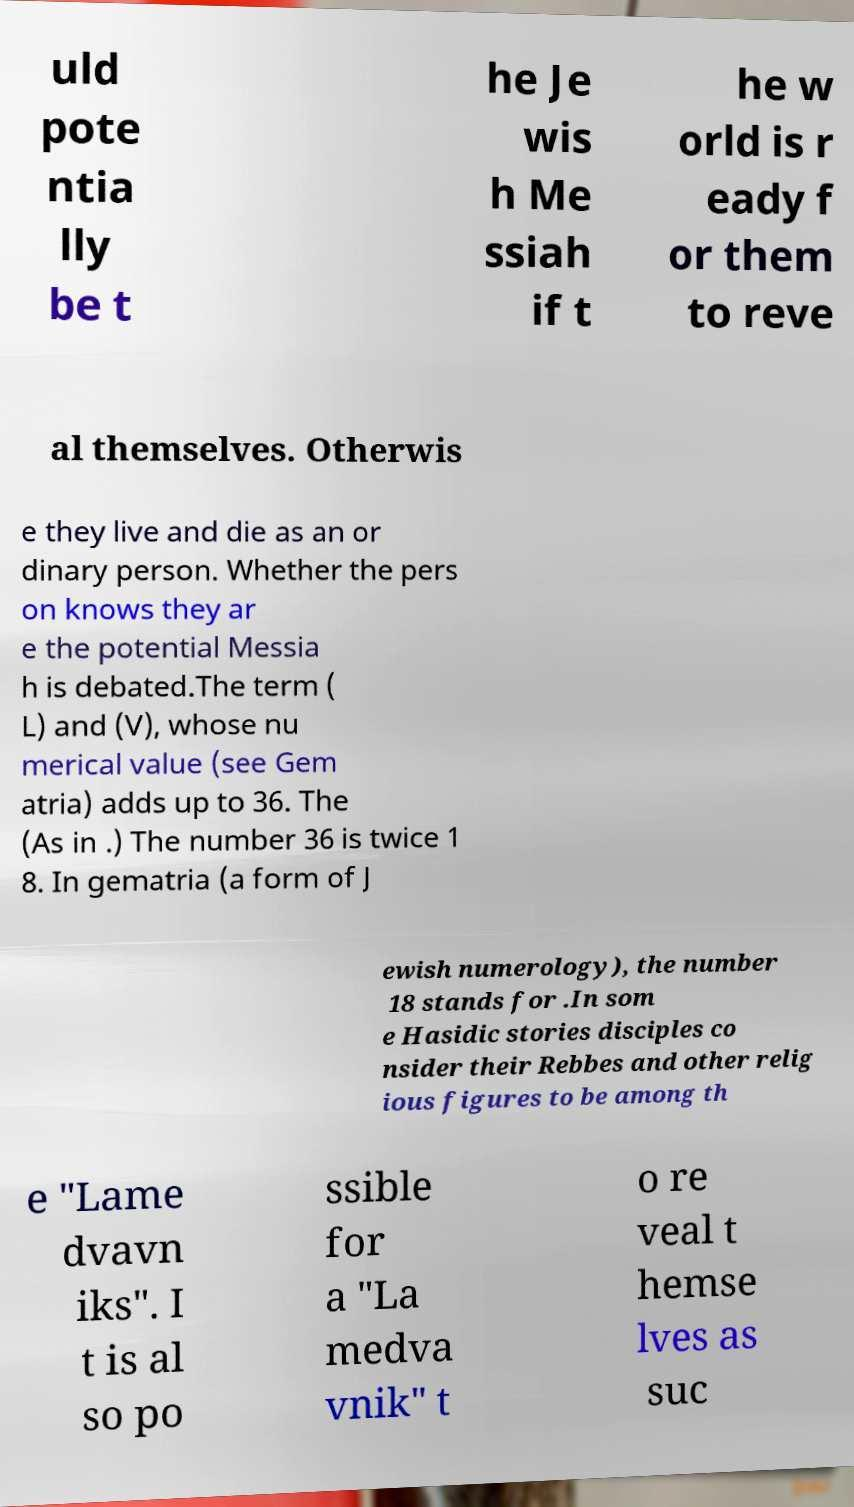I need the written content from this picture converted into text. Can you do that? uld pote ntia lly be t he Je wis h Me ssiah if t he w orld is r eady f or them to reve al themselves. Otherwis e they live and die as an or dinary person. Whether the pers on knows they ar e the potential Messia h is debated.The term ( L) and (V), whose nu merical value (see Gem atria) adds up to 36. The (As in .) The number 36 is twice 1 8. In gematria (a form of J ewish numerology), the number 18 stands for .In som e Hasidic stories disciples co nsider their Rebbes and other relig ious figures to be among th e "Lame dvavn iks". I t is al so po ssible for a "La medva vnik" t o re veal t hemse lves as suc 